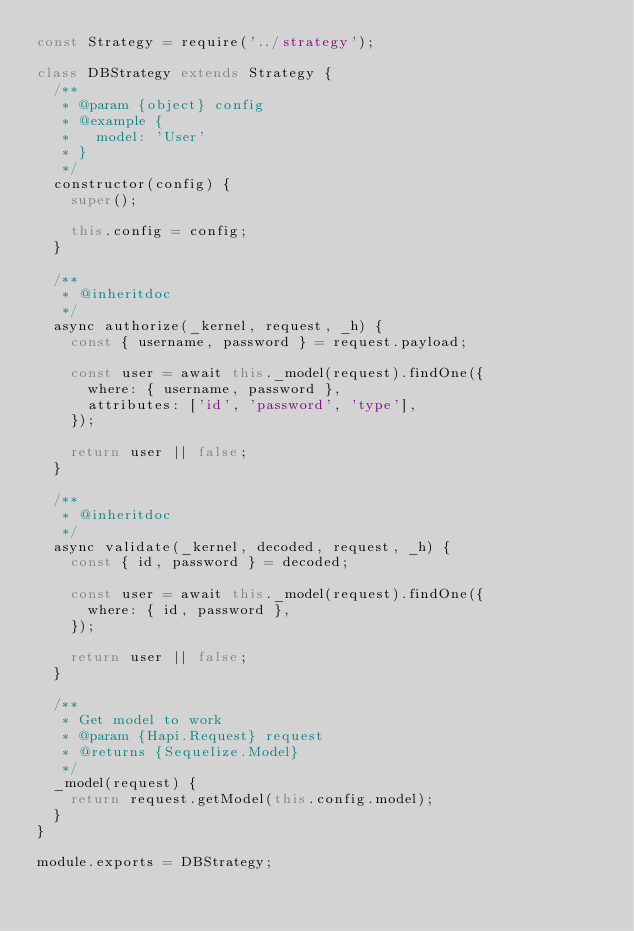<code> <loc_0><loc_0><loc_500><loc_500><_JavaScript_>const Strategy = require('../strategy');

class DBStrategy extends Strategy {
  /**
   * @param {object} config
   * @example {
   *   model: 'User'
   * }
   */
  constructor(config) {
    super();

    this.config = config;
  }

  /**
   * @inheritdoc
   */
  async authorize(_kernel, request, _h) {
    const { username, password } = request.payload;

    const user = await this._model(request).findOne({
      where: { username, password },
      attributes: ['id', 'password', 'type'],
    });

    return user || false;
  }

  /**
   * @inheritdoc
   */
  async validate(_kernel, decoded, request, _h) {
    const { id, password } = decoded;

    const user = await this._model(request).findOne({
      where: { id, password },
    });

    return user || false;
  }

  /**
   * Get model to work
   * @param {Hapi.Request} request
   * @returns {Sequelize.Model}
   */
  _model(request) {
    return request.getModel(this.config.model);
  }
}

module.exports = DBStrategy;
</code> 